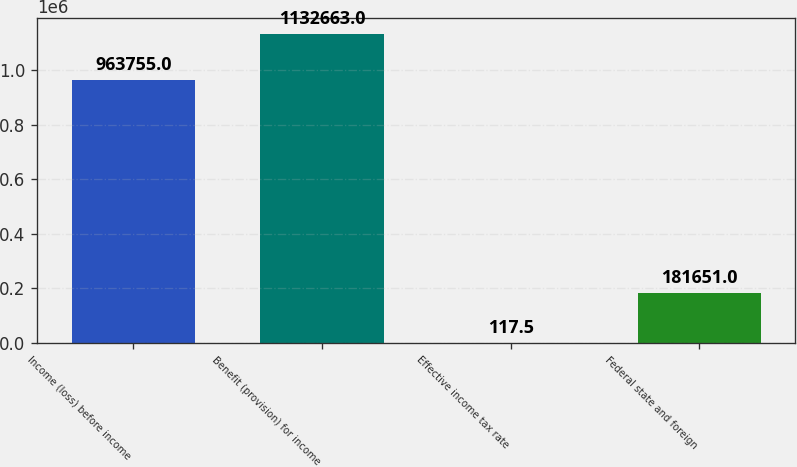Convert chart to OTSL. <chart><loc_0><loc_0><loc_500><loc_500><bar_chart><fcel>Income (loss) before income<fcel>Benefit (provision) for income<fcel>Effective income tax rate<fcel>Federal state and foreign<nl><fcel>963755<fcel>1.13266e+06<fcel>117.5<fcel>181651<nl></chart> 